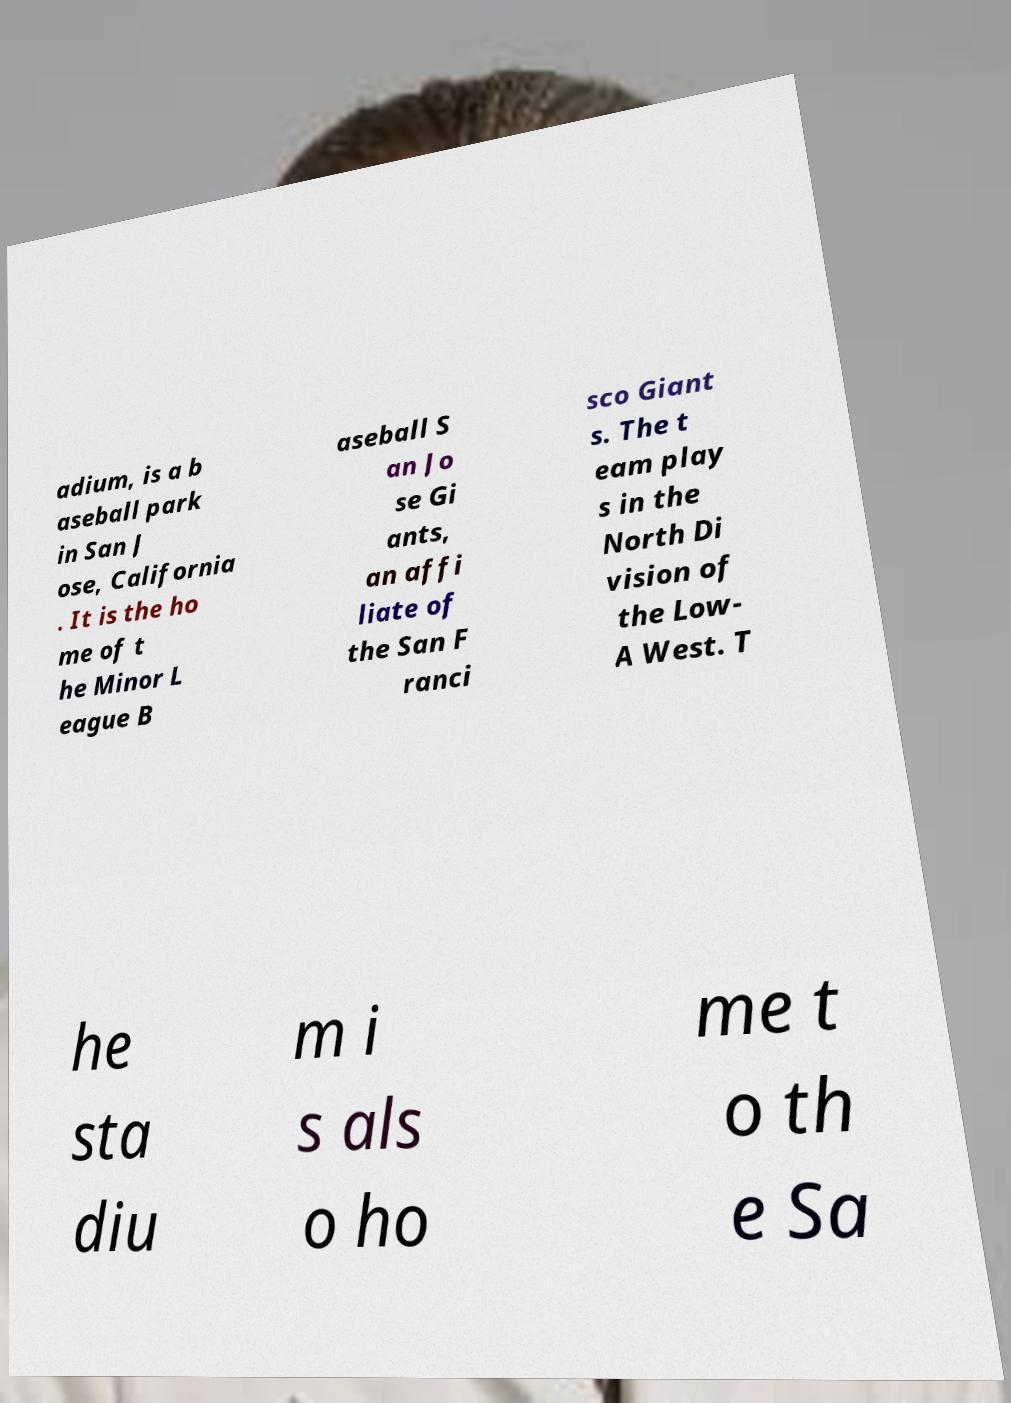Please read and relay the text visible in this image. What does it say? adium, is a b aseball park in San J ose, California . It is the ho me of t he Minor L eague B aseball S an Jo se Gi ants, an affi liate of the San F ranci sco Giant s. The t eam play s in the North Di vision of the Low- A West. T he sta diu m i s als o ho me t o th e Sa 